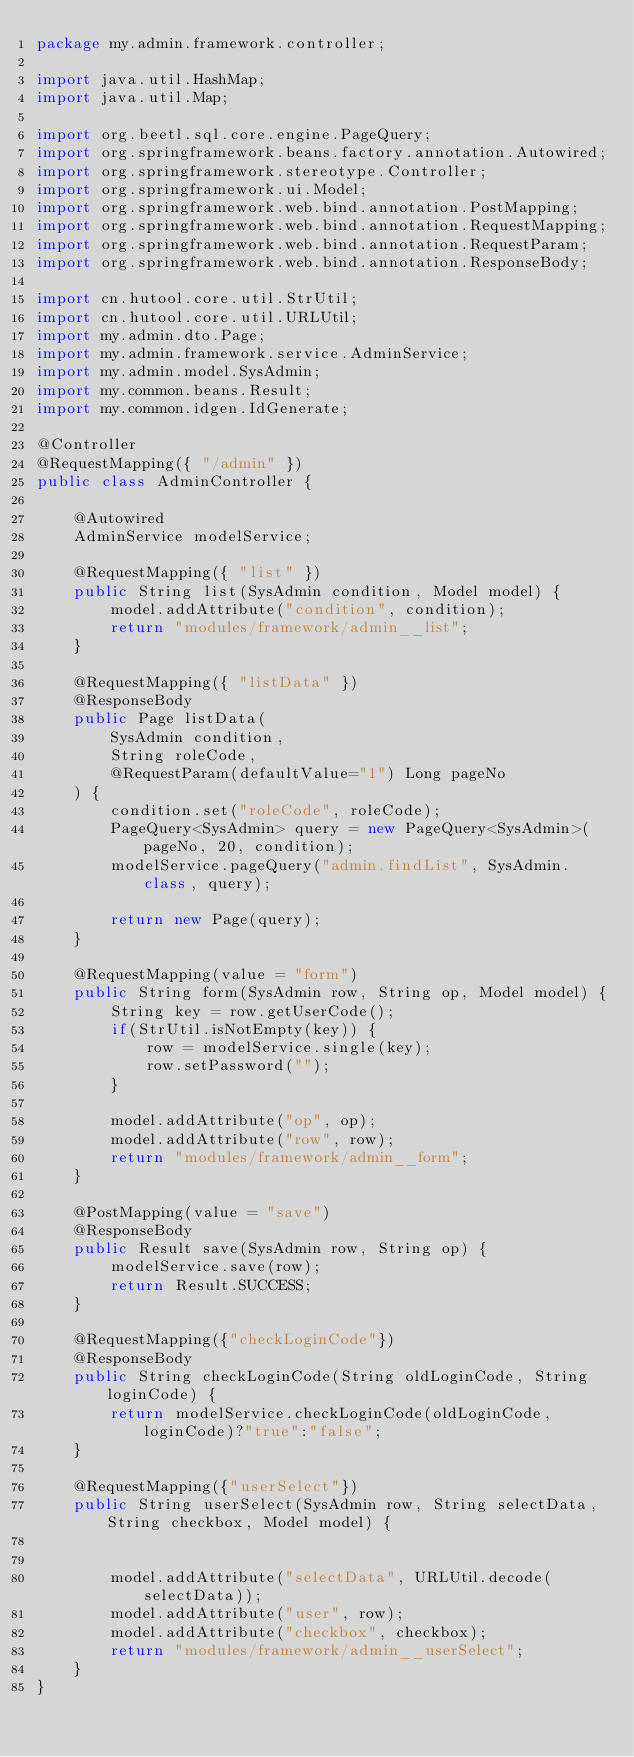<code> <loc_0><loc_0><loc_500><loc_500><_Java_>package my.admin.framework.controller;

import java.util.HashMap;
import java.util.Map;

import org.beetl.sql.core.engine.PageQuery;
import org.springframework.beans.factory.annotation.Autowired;
import org.springframework.stereotype.Controller;
import org.springframework.ui.Model;
import org.springframework.web.bind.annotation.PostMapping;
import org.springframework.web.bind.annotation.RequestMapping;
import org.springframework.web.bind.annotation.RequestParam;
import org.springframework.web.bind.annotation.ResponseBody;

import cn.hutool.core.util.StrUtil;
import cn.hutool.core.util.URLUtil;
import my.admin.dto.Page;
import my.admin.framework.service.AdminService;
import my.admin.model.SysAdmin;
import my.common.beans.Result;
import my.common.idgen.IdGenerate;

@Controller
@RequestMapping({ "/admin" })
public class AdminController {
	
	@Autowired
	AdminService modelService;
	
	@RequestMapping({ "list" })
	public String list(SysAdmin condition, Model model) {
		model.addAttribute("condition", condition);
		return "modules/framework/admin__list";
	}
	
	@RequestMapping({ "listData" })
	@ResponseBody
	public Page listData(
		SysAdmin condition,
		String roleCode,
		@RequestParam(defaultValue="1") Long pageNo
	) {
		condition.set("roleCode", roleCode);
		PageQuery<SysAdmin> query = new PageQuery<SysAdmin>(pageNo, 20, condition);
		modelService.pageQuery("admin.findList", SysAdmin.class, query);
		
		return new Page(query);
	}
	
	@RequestMapping(value = "form")
	public String form(SysAdmin row, String op, Model model) {
		String key = row.getUserCode();
		if(StrUtil.isNotEmpty(key)) {
			row = modelService.single(key);
			row.setPassword("");
		}
		
		model.addAttribute("op", op);
		model.addAttribute("row", row);
		return "modules/framework/admin__form";
	}
	
	@PostMapping(value = "save")
	@ResponseBody
	public Result save(SysAdmin row, String op) {
		modelService.save(row);
		return Result.SUCCESS;
	}
	
	@RequestMapping({"checkLoginCode"})
	@ResponseBody
	public String checkLoginCode(String oldLoginCode, String loginCode) {
		return modelService.checkLoginCode(oldLoginCode, loginCode)?"true":"false";
	}
	
	@RequestMapping({"userSelect"})
	public String userSelect(SysAdmin row, String selectData, String checkbox, Model model) {
		
		
		model.addAttribute("selectData", URLUtil.decode(selectData));
		model.addAttribute("user", row);
		model.addAttribute("checkbox", checkbox);
		return "modules/framework/admin__userSelect";
	}
}
</code> 